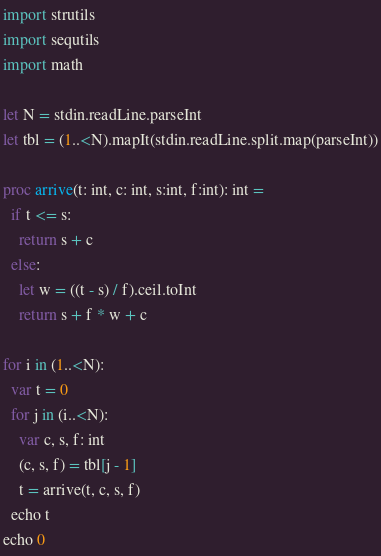Convert code to text. <code><loc_0><loc_0><loc_500><loc_500><_Nim_>import strutils
import sequtils
import math

let N = stdin.readLine.parseInt
let tbl = (1..<N).mapIt(stdin.readLine.split.map(parseInt))

proc arrive(t: int, c: int, s:int, f:int): int =
  if t <= s:
    return s + c
  else:
    let w = ((t - s) / f).ceil.toInt
    return s + f * w + c

for i in (1..<N):
  var t = 0
  for j in (i..<N):
    var c, s, f: int
    (c, s, f) = tbl[j - 1]
    t = arrive(t, c, s, f)
  echo t
echo 0

</code> 